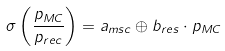Convert formula to latex. <formula><loc_0><loc_0><loc_500><loc_500>\sigma \left ( \frac { p _ { M C } } { p _ { r e c } } \right ) = a _ { m s c } \oplus b _ { r e s } \cdot p _ { M C }</formula> 